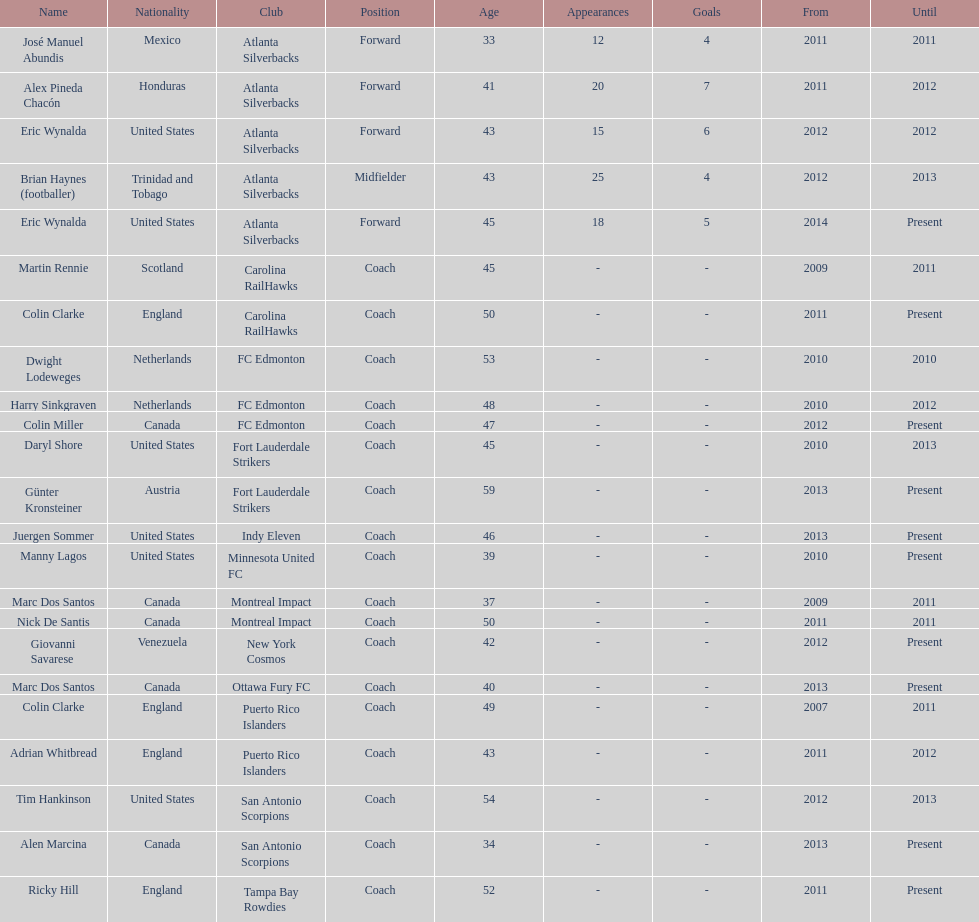How many coaches have coached from america? 6. 